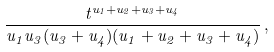Convert formula to latex. <formula><loc_0><loc_0><loc_500><loc_500>\frac { t ^ { u _ { 1 } + u _ { 2 } + u _ { 3 } + u _ { 4 } } } { u _ { 1 } u _ { 3 } ( u _ { 3 } + u _ { 4 } ) ( u _ { 1 } + u _ { 2 } + u _ { 3 } + u _ { 4 } ) } \, ,</formula> 